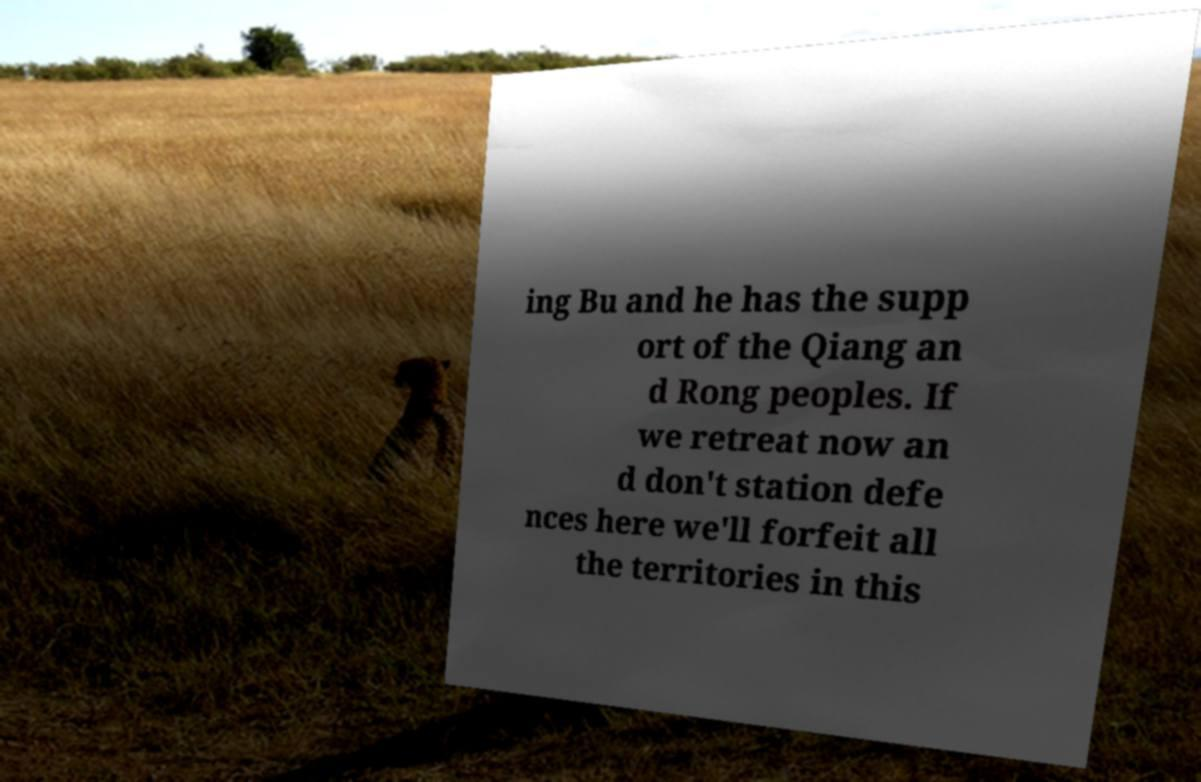What messages or text are displayed in this image? I need them in a readable, typed format. ing Bu and he has the supp ort of the Qiang an d Rong peoples. If we retreat now an d don't station defe nces here we'll forfeit all the territories in this 